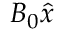<formula> <loc_0><loc_0><loc_500><loc_500>B _ { 0 } \hat { x }</formula> 